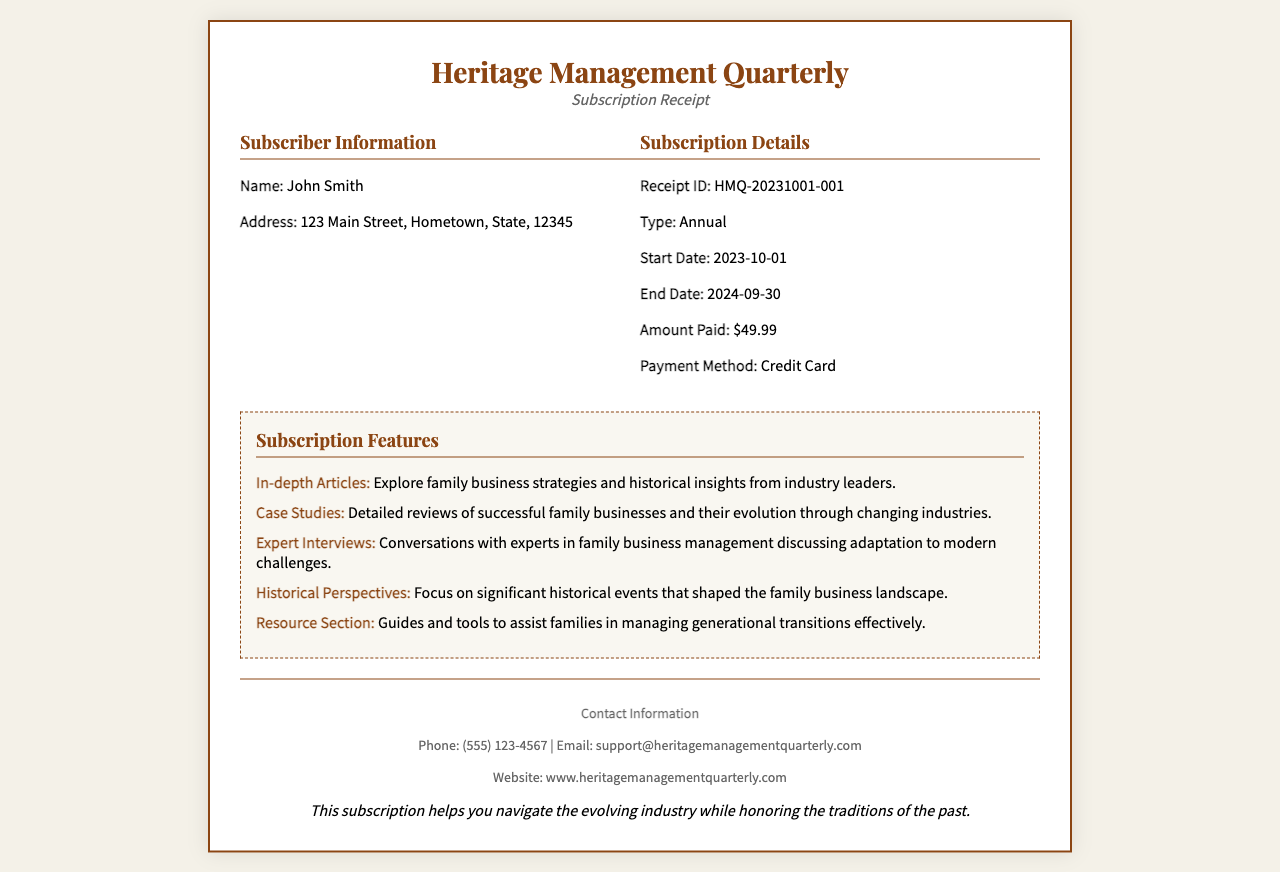What is the name of the magazine? The magazine is called "Heritage Management Quarterly," which is mentioned in the header of the receipt.
Answer: Heritage Management Quarterly Who is the subscriber? The subscriber's name is provided in the receipt, indicating the individual who made the subscription.
Answer: John Smith What is the receipt ID? The specific receipt ID is noted in the Subscription Details section of the document.
Answer: HMQ-20231001-001 What is the start date of the subscription? The document clearly states the start date under Subscription Details.
Answer: 2023-10-01 What amount was paid for the subscription? The total amount paid is specified in the Subscription Details section.
Answer: $49.99 What type of subscription was purchased? The document specifies the type of subscription in the Subscription Details section.
Answer: Annual What feature focuses on family business strategies? One of the features listed in the subscription highlights this aspect specifically.
Answer: In-depth Articles How long is the subscription valid? The end date of the subscription can be used to determine the duration it is active.
Answer: 1 Year What is the contact phone number provided? The document specifies the contact phone number in the footer section.
Answer: (555) 123-4567 